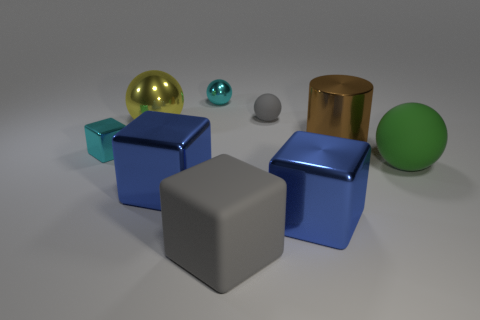What number of other objects are there of the same size as the yellow metal sphere?
Provide a short and direct response. 5. There is a tiny rubber object; is it the same color as the tiny thing that is left of the large yellow object?
Give a very brief answer. No. How many objects are blue things or big yellow metallic balls?
Offer a terse response. 3. Is there anything else that has the same color as the cylinder?
Keep it short and to the point. No. Are the cylinder and the sphere in front of the yellow ball made of the same material?
Your response must be concise. No. What shape is the gray thing on the right side of the large rubber cube that is in front of the cylinder?
Ensure brevity in your answer.  Sphere. There is a rubber object that is both in front of the brown metallic thing and on the left side of the large brown thing; what is its shape?
Your response must be concise. Cube. What number of things are green matte blocks or big things in front of the large rubber ball?
Your response must be concise. 3. There is a cyan object that is the same shape as the big gray rubber object; what is its material?
Make the answer very short. Metal. Is there any other thing that is made of the same material as the large green sphere?
Keep it short and to the point. Yes. 